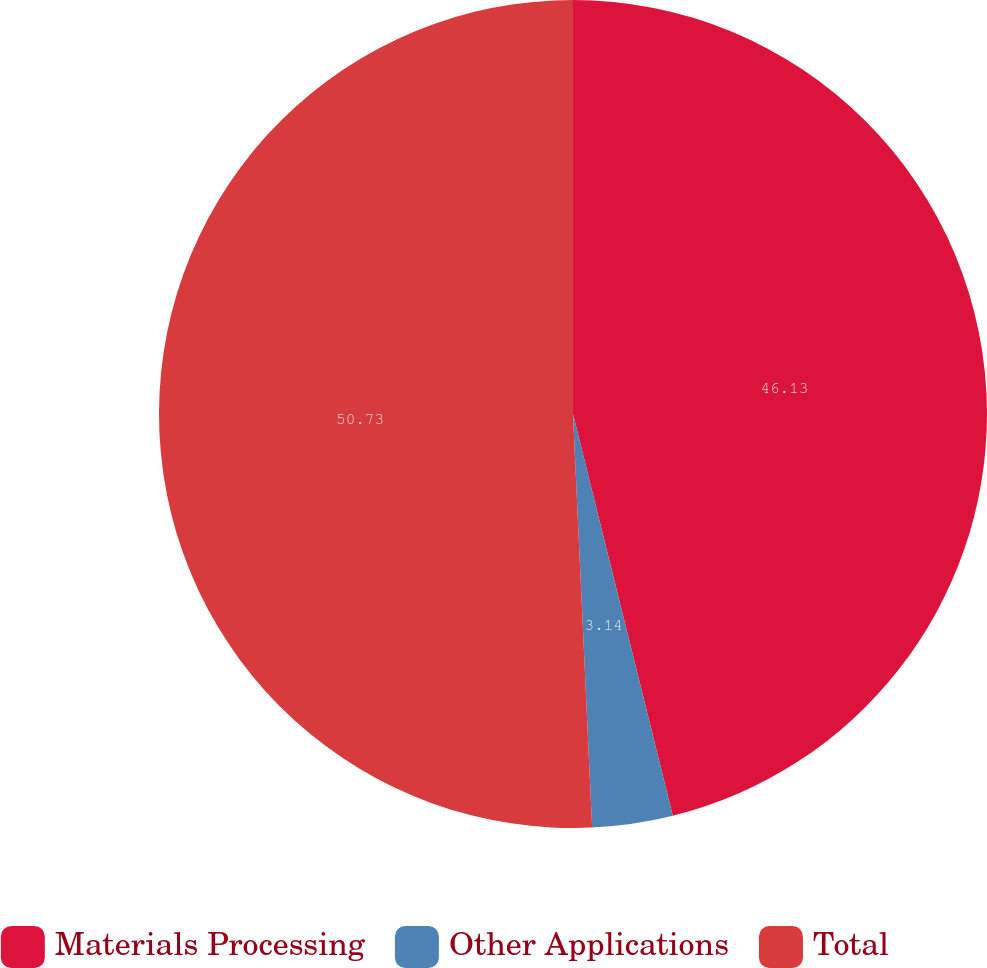Convert chart to OTSL. <chart><loc_0><loc_0><loc_500><loc_500><pie_chart><fcel>Materials Processing<fcel>Other Applications<fcel>Total<nl><fcel>46.13%<fcel>3.14%<fcel>50.74%<nl></chart> 